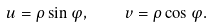Convert formula to latex. <formula><loc_0><loc_0><loc_500><loc_500>u = \rho \sin \varphi , \quad v = \rho \cos \varphi .</formula> 